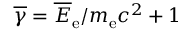<formula> <loc_0><loc_0><loc_500><loc_500>\overline { \gamma } = \overline { E } _ { e } / m _ { e } c ^ { 2 } + 1</formula> 